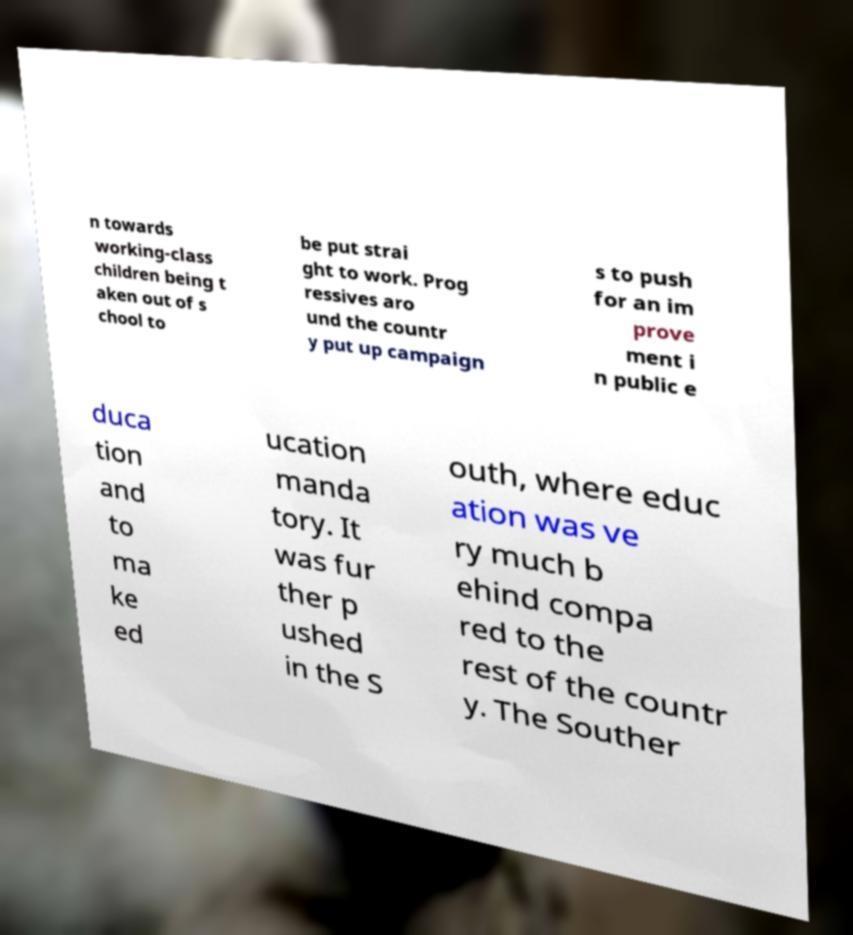Can you read and provide the text displayed in the image?This photo seems to have some interesting text. Can you extract and type it out for me? n towards working-class children being t aken out of s chool to be put strai ght to work. Prog ressives aro und the countr y put up campaign s to push for an im prove ment i n public e duca tion and to ma ke ed ucation manda tory. It was fur ther p ushed in the S outh, where educ ation was ve ry much b ehind compa red to the rest of the countr y. The Souther 